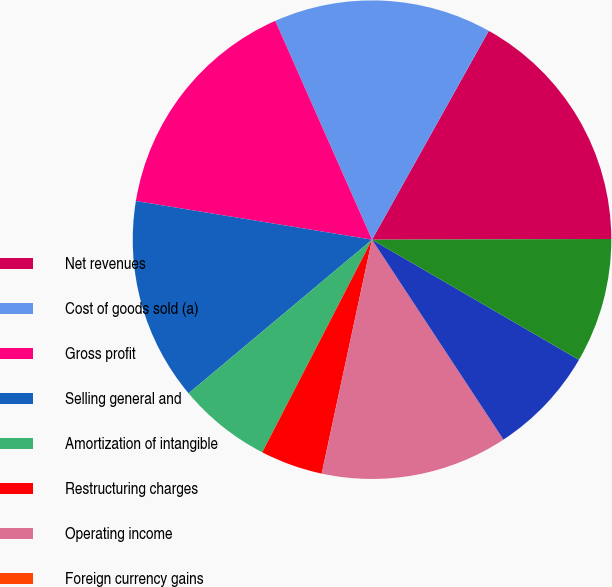Convert chart to OTSL. <chart><loc_0><loc_0><loc_500><loc_500><pie_chart><fcel>Net revenues<fcel>Cost of goods sold (a)<fcel>Gross profit<fcel>Selling general and<fcel>Amortization of intangible<fcel>Restructuring charges<fcel>Operating income<fcel>Foreign currency gains<fcel>Interest expense<fcel>Interest and other income net<nl><fcel>16.84%<fcel>14.74%<fcel>15.79%<fcel>13.68%<fcel>6.32%<fcel>4.21%<fcel>12.63%<fcel>0.0%<fcel>7.37%<fcel>8.42%<nl></chart> 